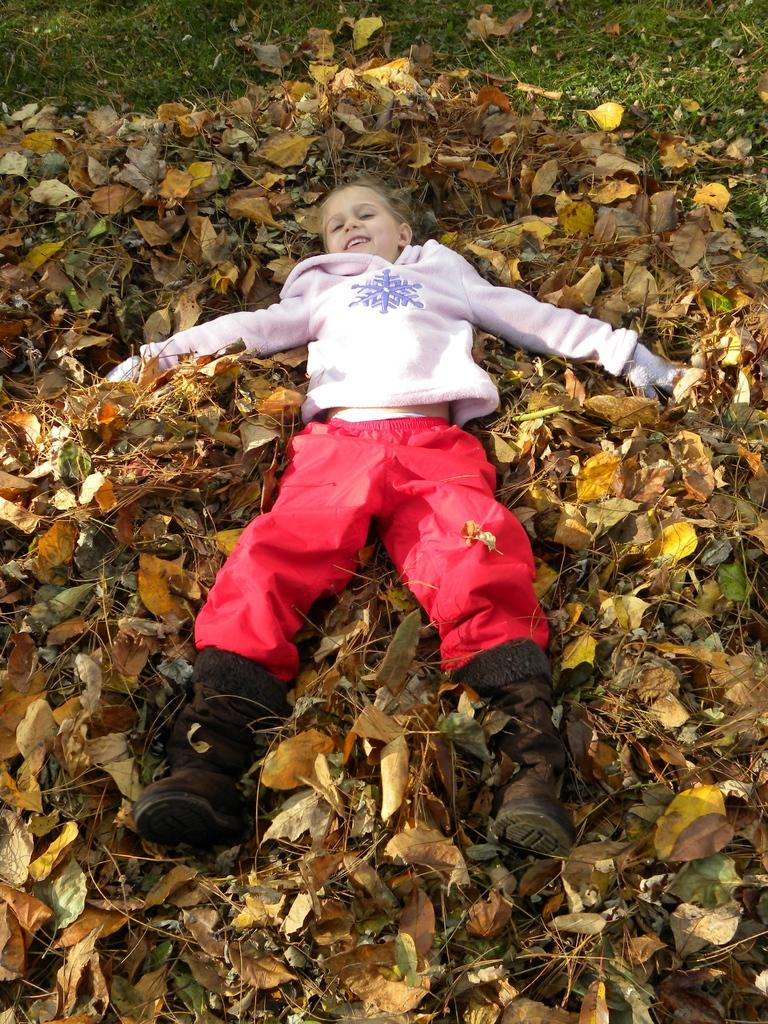What is the main subject of the image? There is a kid in the image. What can be seen in the background of the image? There are dry leaves in the background of the image. What type of vegetation is visible at the top of the image? There is grass visible at the top of the image. How does the kid's digestion process appear in the image? There is no indication of the kid's digestion process in the image. What is in the kid's pocket in the image? There is no pocket visible on the kid in the image. 